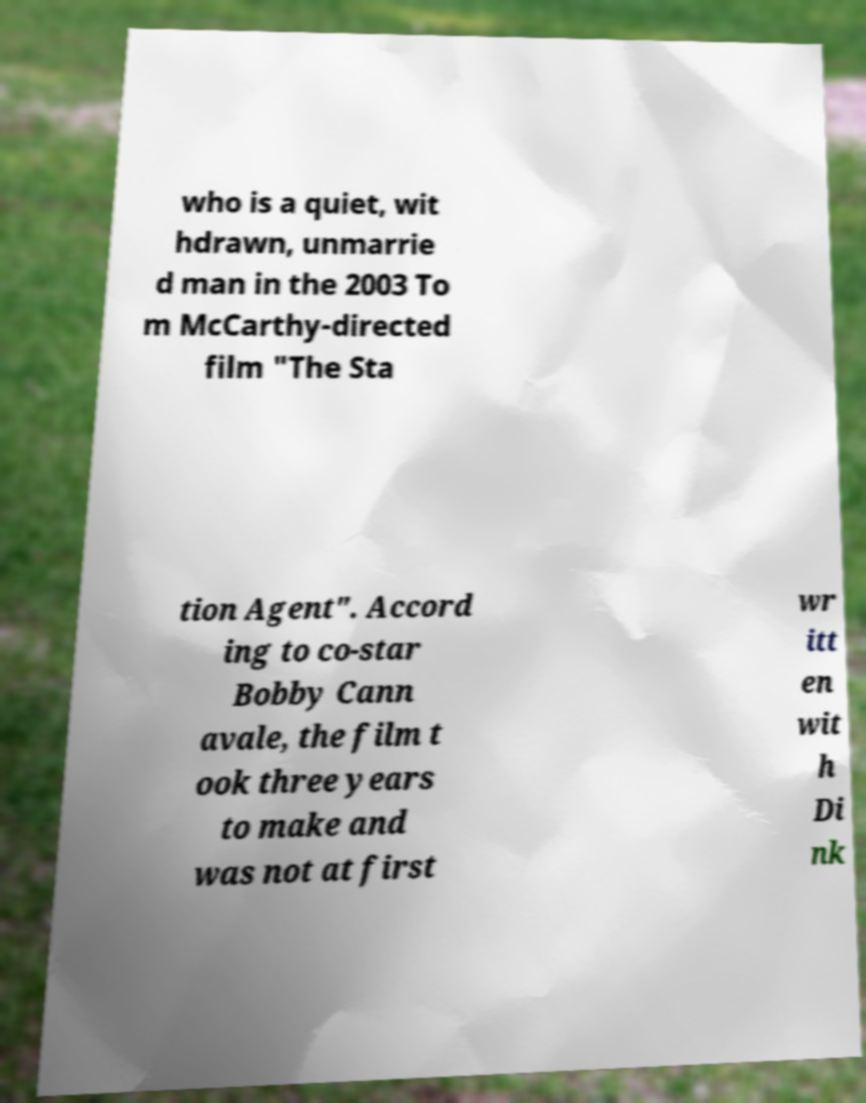Could you extract and type out the text from this image? who is a quiet, wit hdrawn, unmarrie d man in the 2003 To m McCarthy-directed film "The Sta tion Agent". Accord ing to co-star Bobby Cann avale, the film t ook three years to make and was not at first wr itt en wit h Di nk 